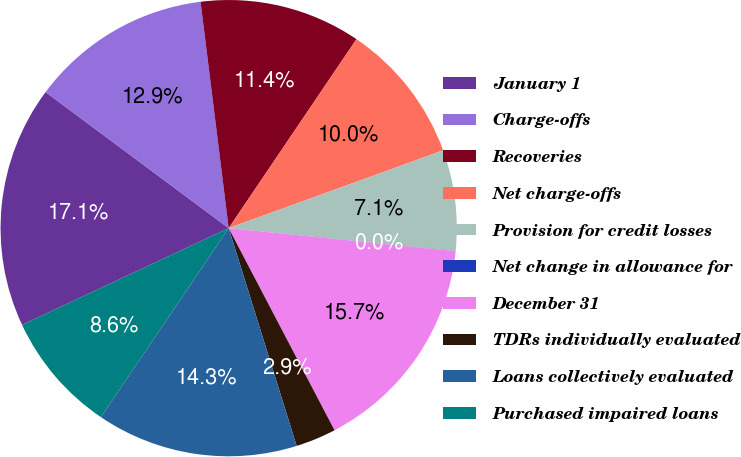Convert chart to OTSL. <chart><loc_0><loc_0><loc_500><loc_500><pie_chart><fcel>January 1<fcel>Charge-offs<fcel>Recoveries<fcel>Net charge-offs<fcel>Provision for credit losses<fcel>Net change in allowance for<fcel>December 31<fcel>TDRs individually evaluated<fcel>Loans collectively evaluated<fcel>Purchased impaired loans<nl><fcel>17.14%<fcel>12.86%<fcel>11.43%<fcel>10.0%<fcel>7.14%<fcel>0.01%<fcel>15.71%<fcel>2.86%<fcel>14.28%<fcel>8.57%<nl></chart> 